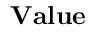Convert formula to latex. <formula><loc_0><loc_0><loc_500><loc_500>V a l u e</formula> 